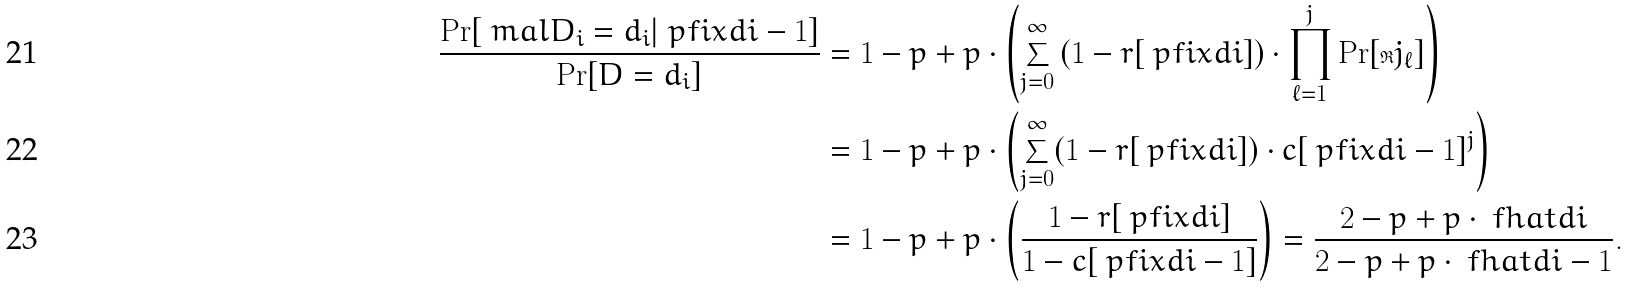Convert formula to latex. <formula><loc_0><loc_0><loc_500><loc_500>\frac { \Pr [ \ m a l { D } _ { i } = d _ { i } | \ p f i x { d } { i - 1 } ] } { \Pr [ D = d _ { i } ] } & = 1 - p + p \cdot \left ( \sum _ { j = 0 } ^ { \infty } \left ( 1 - r [ \ p f i x { d } { i } ] \right ) \cdot \prod _ { \ell = 1 } ^ { j } \Pr [ \Re j _ { \ell } ] \right ) \\ & = 1 - p + p \cdot \left ( \sum _ { j = 0 } ^ { \infty } ( 1 - r [ \ p f i x { d } { i } ] ) \cdot c [ \ p f i x { d } { i - 1 } ] ^ { j } \right ) \\ & = 1 - p + p \cdot \left ( \frac { 1 - r [ \ p f i x { d } { i } ] } { 1 - c [ \ p f i x { d } { i - 1 } ] } \right ) = \frac { 2 - p + p \cdot \ f h a t { d } { i } } { 2 - p + p \cdot \ f h a t { d } { i - 1 } } .</formula> 